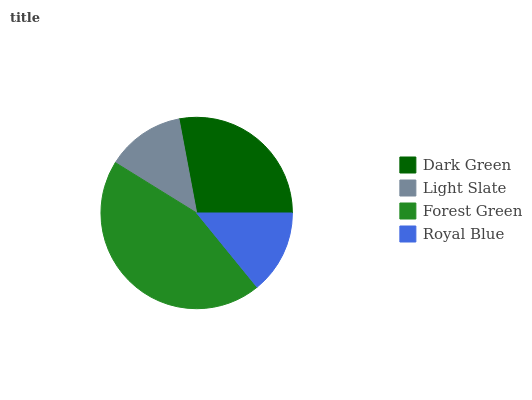Is Light Slate the minimum?
Answer yes or no. Yes. Is Forest Green the maximum?
Answer yes or no. Yes. Is Forest Green the minimum?
Answer yes or no. No. Is Light Slate the maximum?
Answer yes or no. No. Is Forest Green greater than Light Slate?
Answer yes or no. Yes. Is Light Slate less than Forest Green?
Answer yes or no. Yes. Is Light Slate greater than Forest Green?
Answer yes or no. No. Is Forest Green less than Light Slate?
Answer yes or no. No. Is Dark Green the high median?
Answer yes or no. Yes. Is Royal Blue the low median?
Answer yes or no. Yes. Is Royal Blue the high median?
Answer yes or no. No. Is Light Slate the low median?
Answer yes or no. No. 